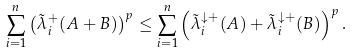Convert formula to latex. <formula><loc_0><loc_0><loc_500><loc_500>\sum _ { i = 1 } ^ { n } \left ( \tilde { \lambda } _ { i } ^ { + } ( A + B ) \right ) ^ { p } \leq \sum _ { i = 1 } ^ { n } \left ( \tilde { \lambda } _ { i } ^ { \downarrow + } ( A ) + \tilde { \lambda } _ { i } ^ { \downarrow + } ( B ) \right ) ^ { p } .</formula> 